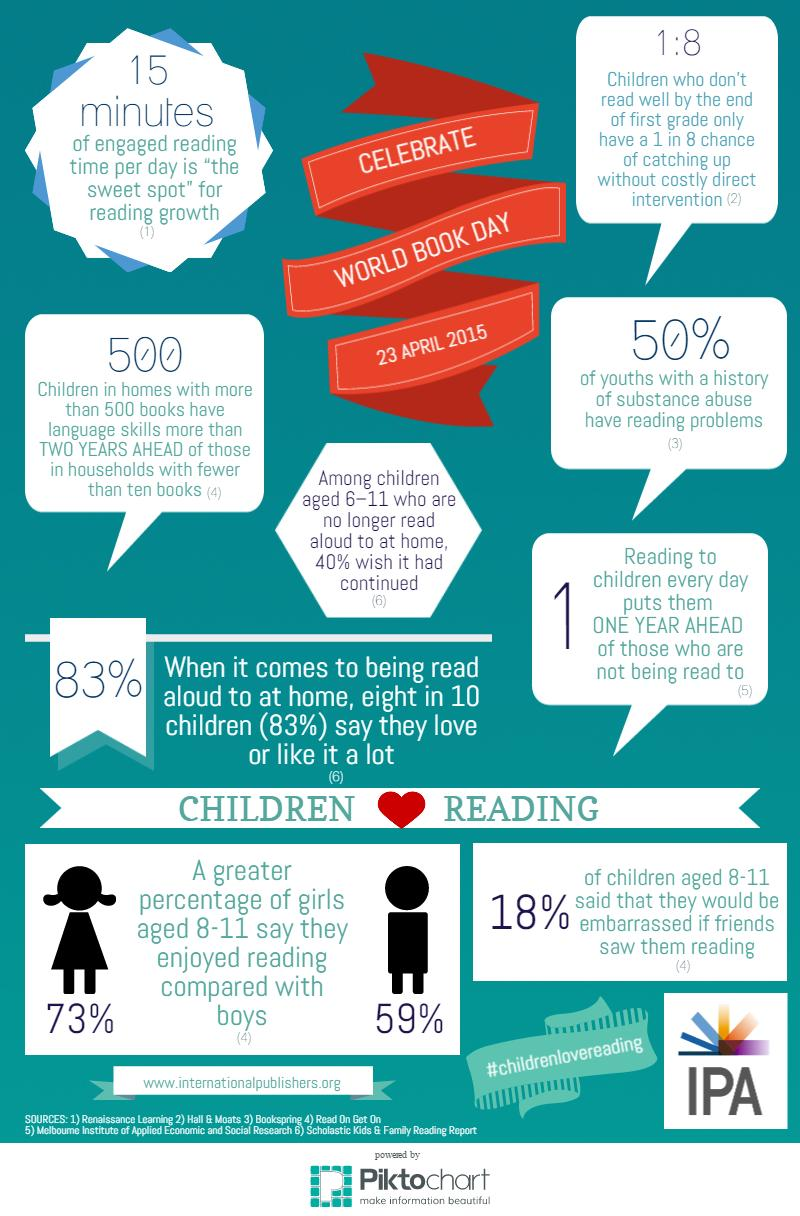Give some essential details in this illustration. In the survey of girls aged 8-11, 73% reported enjoying reading. Research indicates that approximately 50% of individuals with addiction issues also struggle with reading difficulties. According to the given data, it is revealed that 59% of boys aged 8-11 enjoyed reading. 